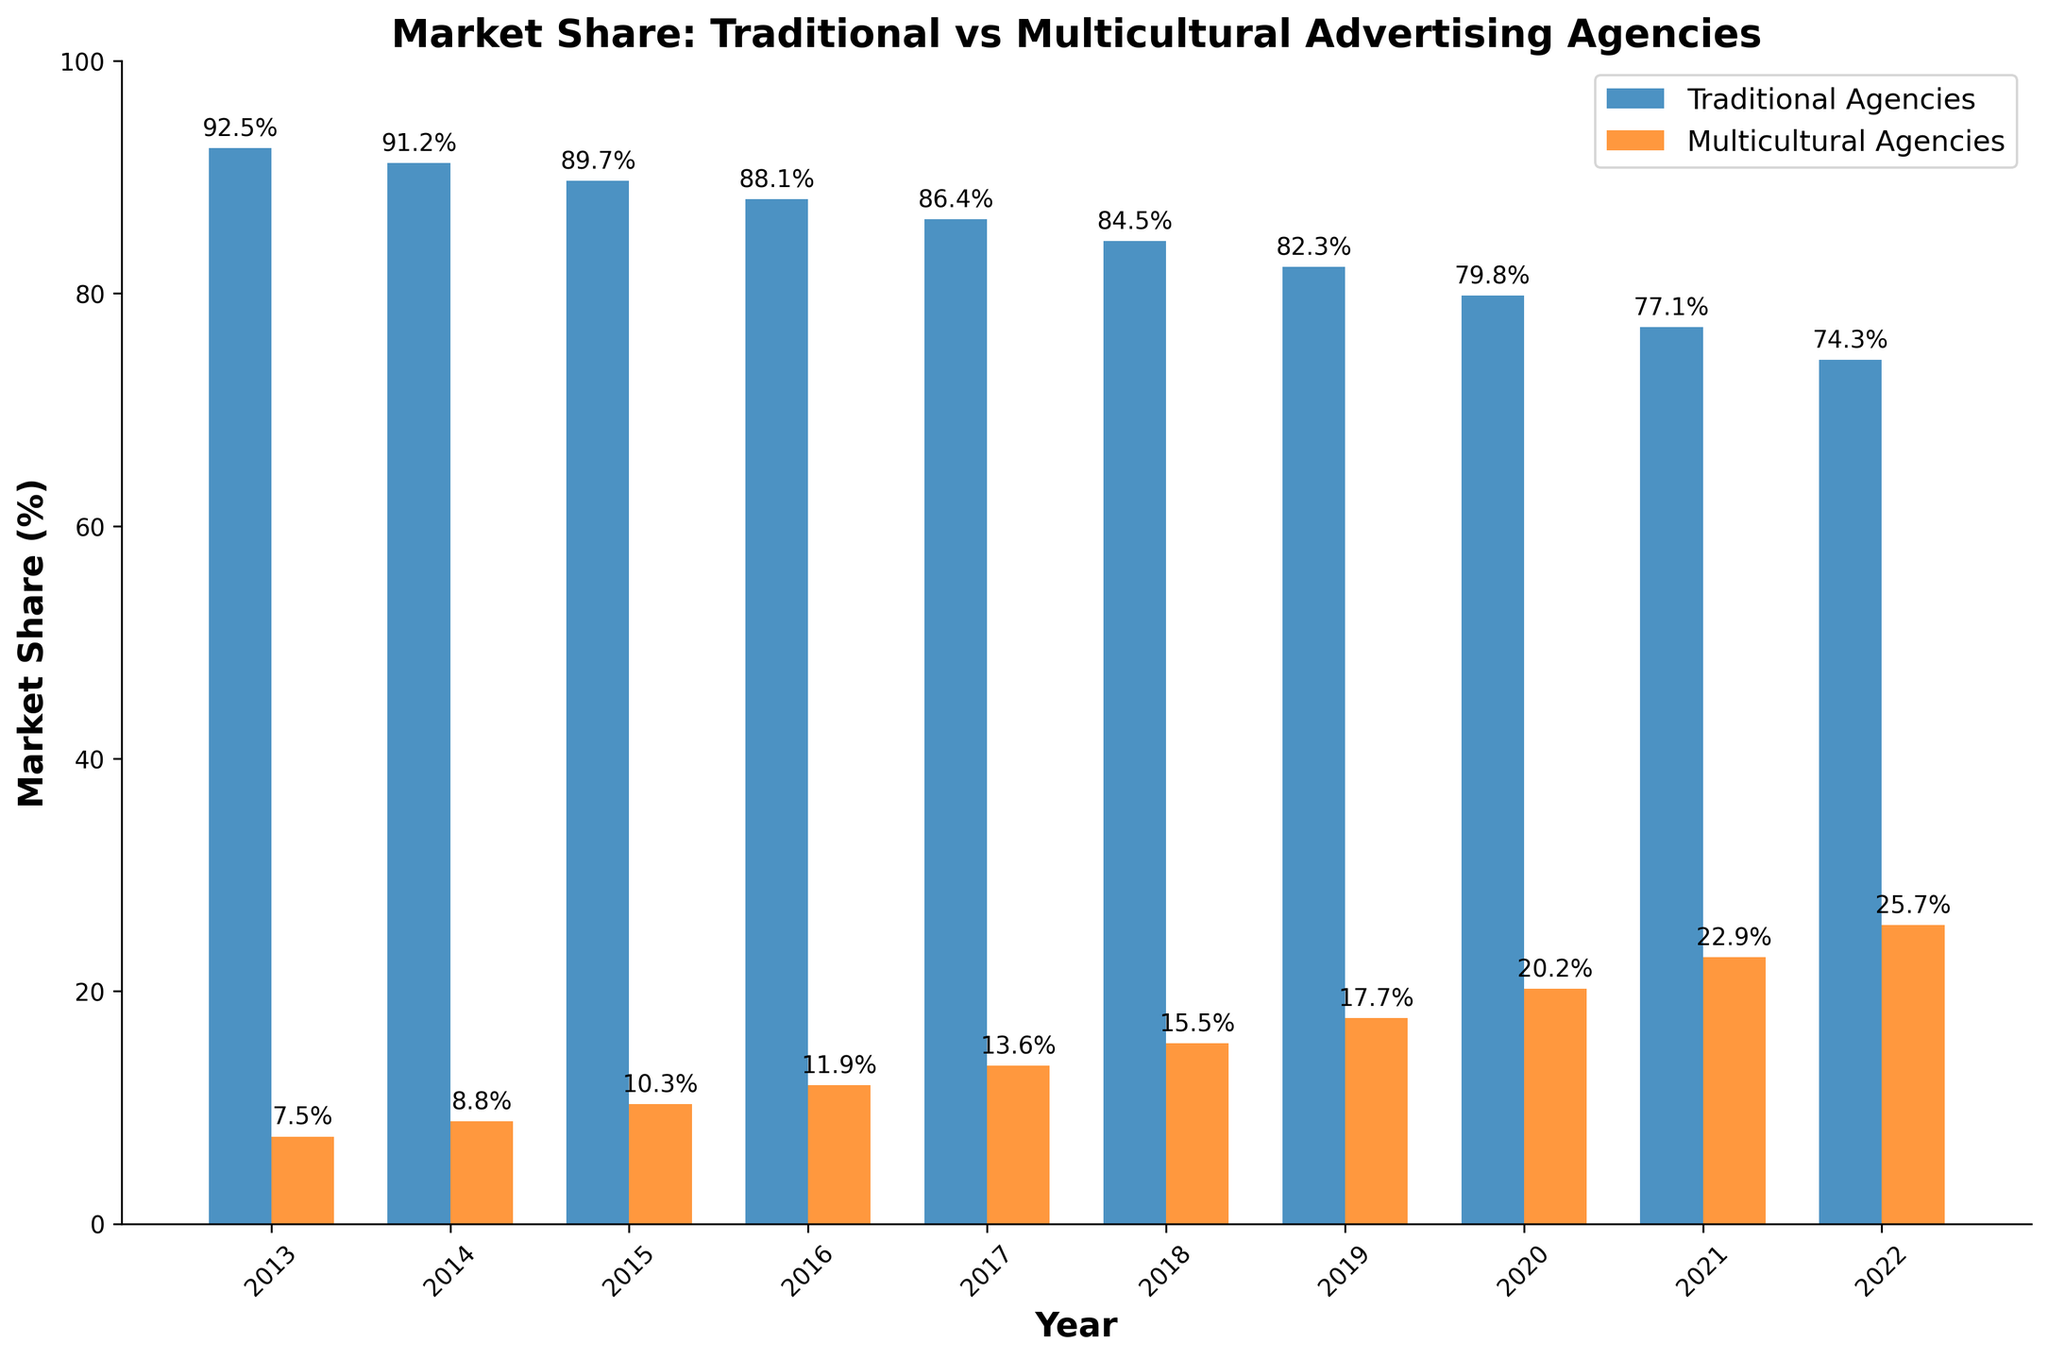What is the main trend observed in the market share of multicultural agencies over the past decade? The figure shows a consistent increase in the market share of multicultural agencies from 7.5% in 2013 to 25.7% in 2022. This indicates a gradual rise in their influence over the studied period.
Answer: Increase How much did the market share of traditional agencies decrease from 2013 to 2022? The market share of traditional agencies in 2013 was 92.5%, and in 2022 it was 74.3%. The decrease is 92.5% - 74.3% = 18.2%.
Answer: 18.2% In which year did multicultural agencies surpass 20% market share? By inspecting the figure, it is evident that multicultural agencies had a market share of 20.2% in 2020, thus surpassing 20% in that year.
Answer: 2020 How does the market share of traditional agencies in 2022 compare to that in 2017? Traditional agencies had a market share of 74.3% in 2022 and 86.4% in 2017. Hence, the market share in 2022 is significantly lower than in 2017.
Answer: Lower What is the average market share of multicultural agencies over the decade? Summing up the market share percentages of multicultural agencies from 2013 to 2022 (7.5 + 8.8 + 10.3 + 11.9 + 13.6 + 15.5 + 17.7 + 20.2 + 22.9 + 25.7 = 154.1) and dividing by the number of years (10) gives an average of 154.1 / 10 = 15.41%.
Answer: 15.41% By how many percentage points did the market share of multicultural agencies increase from 2018 to 2021? The market share in 2018 was 15.5%, and in 2021 it was 22.9%. The increase is 22.9% - 15.5% = 7.4%.
Answer: 7.4% Which year experienced the largest single-year increase in the market share for multicultural agencies? Comparing the year-by-year increases, the largest single-year increase occurred from 2019 to 2020, where the market share rose from 17.7% to 20.2%, an increase of 2.5%.
Answer: 2020 How did the market share of traditional agencies change between 2014 and 2016? The market share of traditional agencies in 2014 was 91.2%, and in 2016 it was 88.1%. Thus, the change over these years is a decrease of 91.2% - 88.1% = 3.1%.
Answer: Decreased by 3.1% Comparing the bars for 2015, which agency type had the taller bar, and by how much? In 2015, the market share of traditional agencies (89.7%) was taller than that of multicultural agencies (10.3%). The difference is 89.7% - 10.3% = 79.4%.
Answer: Traditional agencies by 79.4% What is the relative change in market share for traditional agencies from 2013 to 2022 as a proportion of their market share in 2013? The change in market share from 2013 to 2022 is 74.3% - 92.5% = -18.2%. The relative change is -18.2% / 92.5% ≈ -0.197, or approximately -19.7%.
Answer: -19.7% 